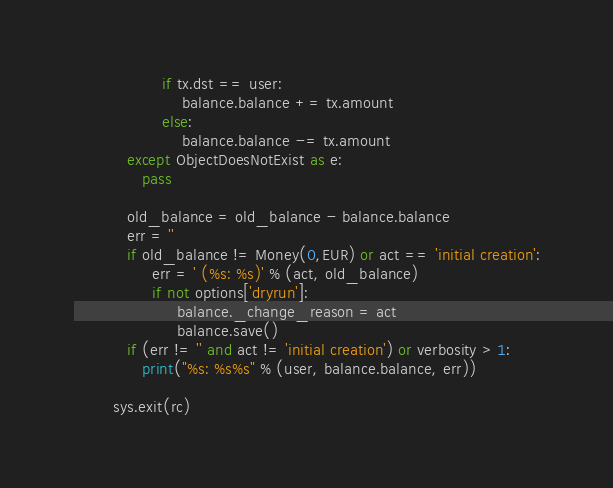Convert code to text. <code><loc_0><loc_0><loc_500><loc_500><_Python_>                  if tx.dst == user:
                      balance.balance += tx.amount
                  else:
                      balance.balance -= tx.amount
           except ObjectDoesNotExist as e:
              pass

           old_balance = old_balance - balance.balance
           err = ''
           if old_balance != Money(0,EUR) or act == 'initial creation':
                err = ' (%s: %s)' % (act, old_balance)
                if not options['dryrun']:
                     balance._change_reason = act
                     balance.save()
           if (err != '' and act != 'initial creation') or verbosity > 1:
              print("%s: %s%s" % (user, balance.balance, err))

        sys.exit(rc)
</code> 